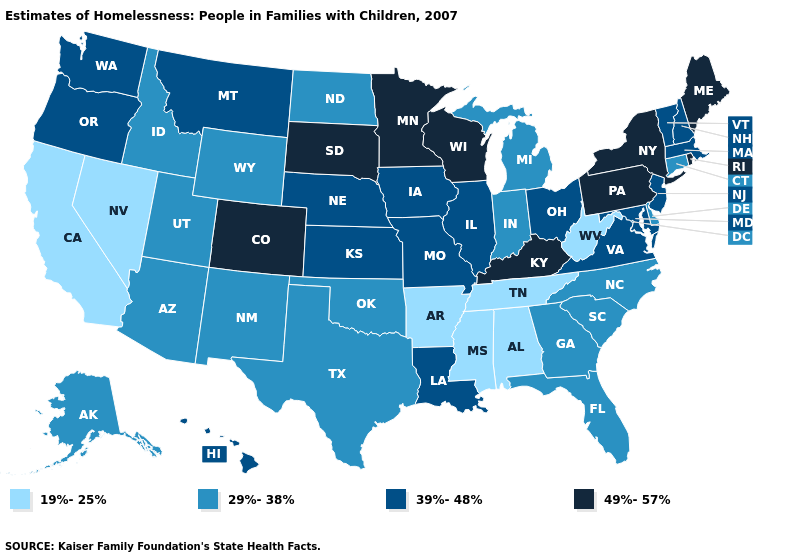Does Indiana have the same value as Wyoming?
Short answer required. Yes. How many symbols are there in the legend?
Short answer required. 4. What is the value of Arkansas?
Concise answer only. 19%-25%. What is the value of Kentucky?
Answer briefly. 49%-57%. Which states hav the highest value in the Northeast?
Quick response, please. Maine, New York, Pennsylvania, Rhode Island. Which states have the lowest value in the MidWest?
Keep it brief. Indiana, Michigan, North Dakota. What is the highest value in states that border New Hampshire?
Give a very brief answer. 49%-57%. Name the states that have a value in the range 29%-38%?
Concise answer only. Alaska, Arizona, Connecticut, Delaware, Florida, Georgia, Idaho, Indiana, Michigan, New Mexico, North Carolina, North Dakota, Oklahoma, South Carolina, Texas, Utah, Wyoming. How many symbols are there in the legend?
Concise answer only. 4. Which states have the highest value in the USA?
Be succinct. Colorado, Kentucky, Maine, Minnesota, New York, Pennsylvania, Rhode Island, South Dakota, Wisconsin. Does Maryland have the lowest value in the South?
Answer briefly. No. Does Pennsylvania have the lowest value in the Northeast?
Be succinct. No. What is the highest value in states that border Texas?
Quick response, please. 39%-48%. Which states have the highest value in the USA?
Keep it brief. Colorado, Kentucky, Maine, Minnesota, New York, Pennsylvania, Rhode Island, South Dakota, Wisconsin. Does Alaska have the highest value in the USA?
Short answer required. No. 